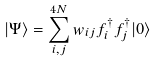<formula> <loc_0><loc_0><loc_500><loc_500>| \Psi \rangle = \sum _ { i , j } ^ { 4 N } w _ { i j } f _ { i } ^ { \dag } f _ { j } ^ { \dag } | 0 \rangle</formula> 